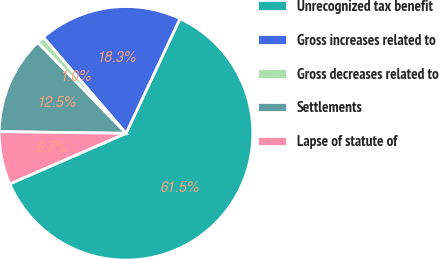Convert chart. <chart><loc_0><loc_0><loc_500><loc_500><pie_chart><fcel>Unrecognized tax benefit<fcel>Gross increases related to<fcel>Gross decreases related to<fcel>Settlements<fcel>Lapse of statute of<nl><fcel>61.47%<fcel>18.31%<fcel>0.96%<fcel>12.52%<fcel>6.74%<nl></chart> 